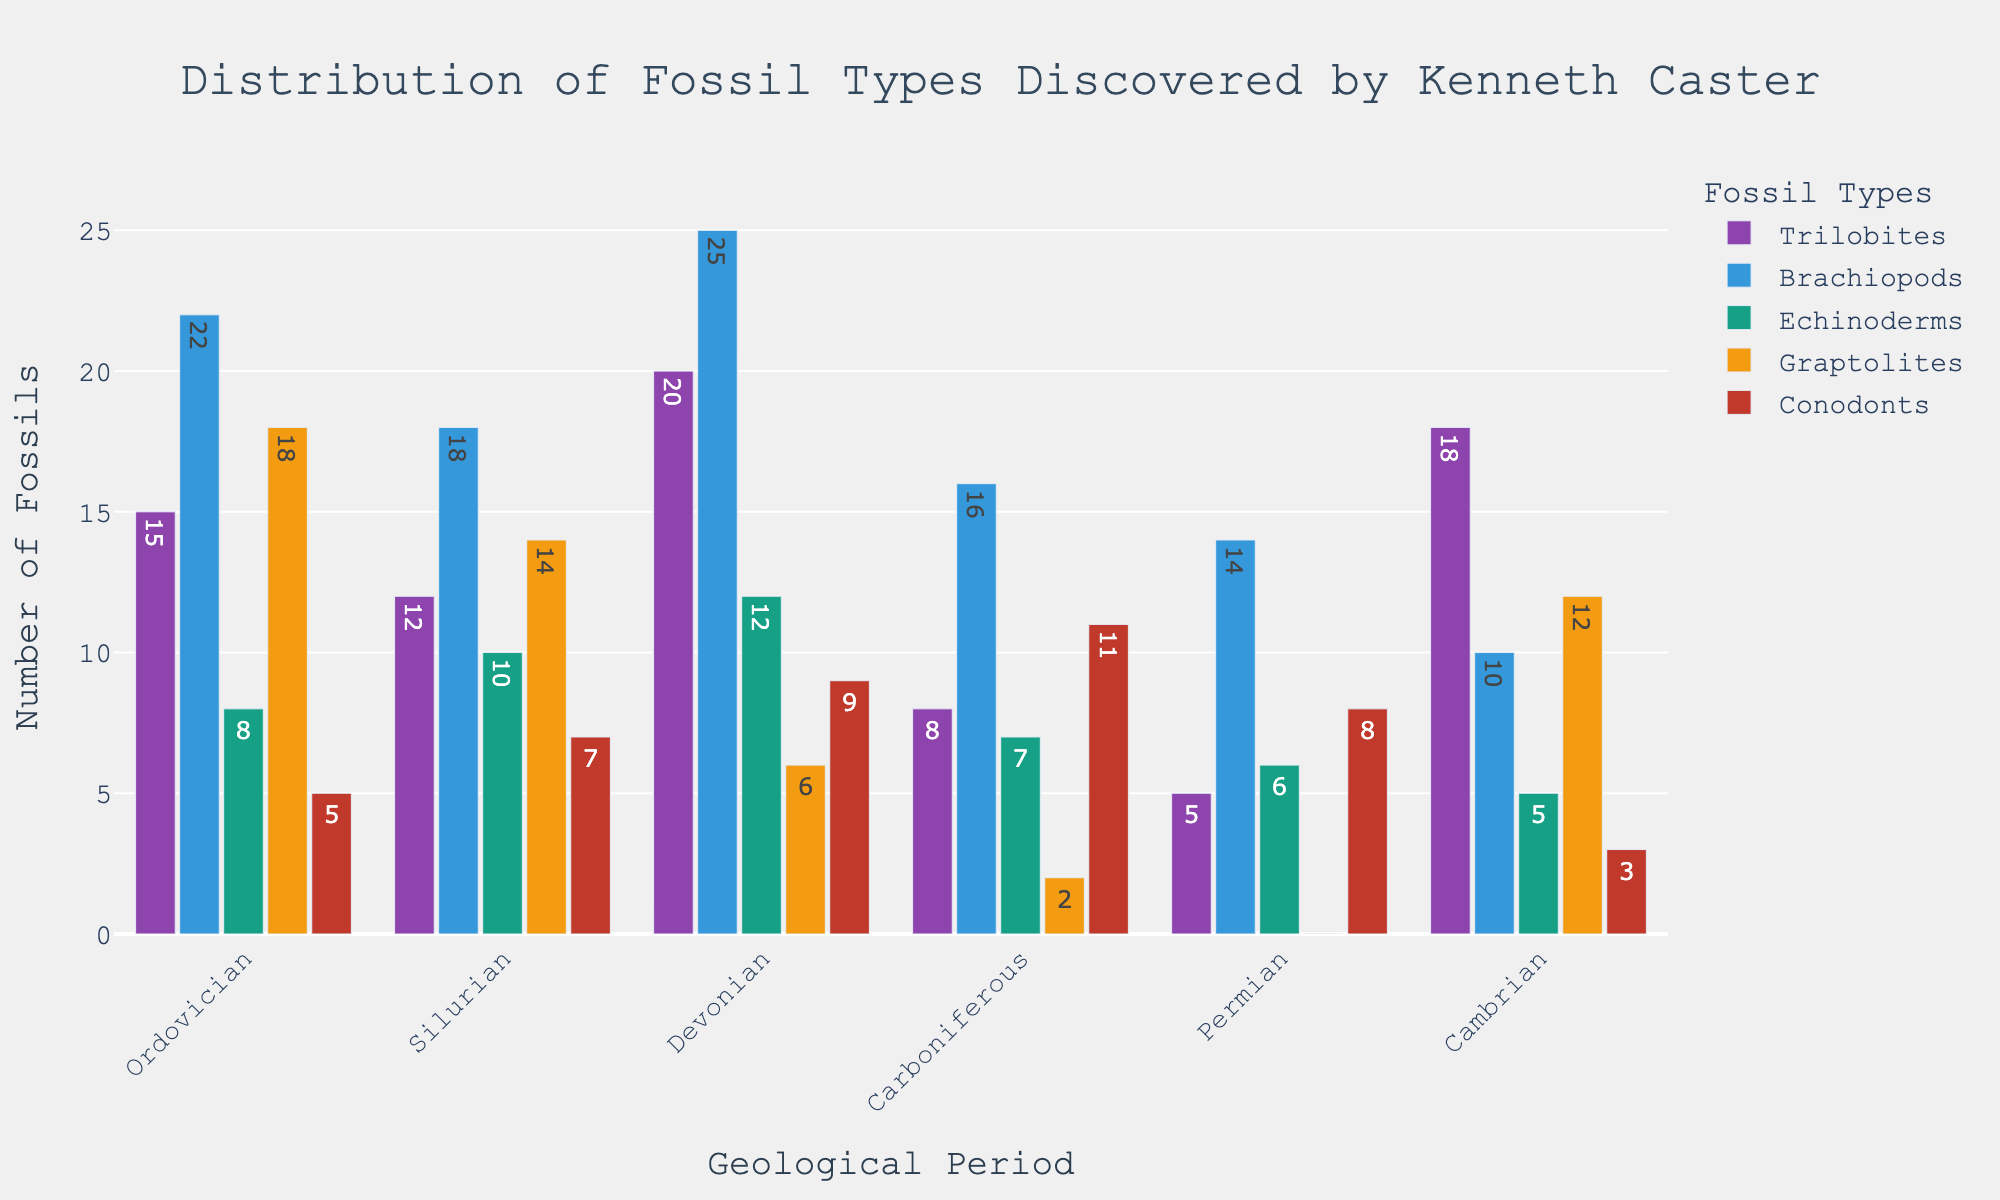What is the total number of Trilobite fossils discovered across all geological periods? Add the number of Trilobite fossils for each period: 15 (Ordovician) + 12 (Silurian) + 20 (Devonian) + 8 (Carboniferous) + 5 (Permian) + 18 (Cambrian) = 78
Answer: 78 Which geological period had the highest number of Brachiopod fossils? Compare the Brachiopod fossil counts across periods: 22 (Ordovician), 18 (Silurian), 25 (Devonian), 16 (Carboniferous), 14 (Permian), 10 (Cambrian). The highest count is 25 in the Devonian.
Answer: Devonian Are the number of Echinoderm fossils in the Silurian and Carboniferous periods greater than the Ordovician period combined? Sum the Echinoderm fossils for Silurian and Carboniferous: 10 + 7 = 17. Compare with the Ordovician: 8. 17 is greater than 8.
Answer: Yes How many more Graptolite fossils were discovered in the Ordovician compared to the Carboniferous? Subtract the Graptolite fossils in the Carboniferous from those in the Ordovician: 18 (Ordovician) - 2 (Carboniferous) = 16
Answer: 16 Which fossil type has the most significant drop in number from the Devonian to the Permian period? Compare the difference in fossil counts from Devonian to Permian for each type: Trilobites (20-5=15), Brachiopods (25-14=11), Echinoderms (12-6=6), Graptolites (6-0=6), Conodonts (9-8=1). The largest drop is in Trilobites (15).
Answer: Trilobites What is the average number of fossils found per geological period for Conodonts? Add the number of Conodont fossils for each period: 5 + 7 + 9 + 11 + 8 + 3 = 43. Divide by the number of periods: 43 / 6 ≈ 7.17
Answer: 7.17 Which geological period had the least number of total fossils discovered? Sum the fossils for each period: Ordovician (68), Silurian (61), Devonian (72), Carboniferous (44), Permian (33), Cambrian (48). The period with the least total is Permian (33).
Answer: Permian Is the total number of Brachiopod fossils greater than the total number of Echinoderm fossils across all periods? Sum the counts: Brachiopods (22 + 18 + 25 + 16 + 14 + 10 = 105), Echinoderms (8 + 10 + 12 + 7 + 6 + 5 = 48). 105 is greater than 48.
Answer: Yes What color represents the Graptolites on the chart? In the figure, the Graptolites are represented by the orange bars.
Answer: Orange 